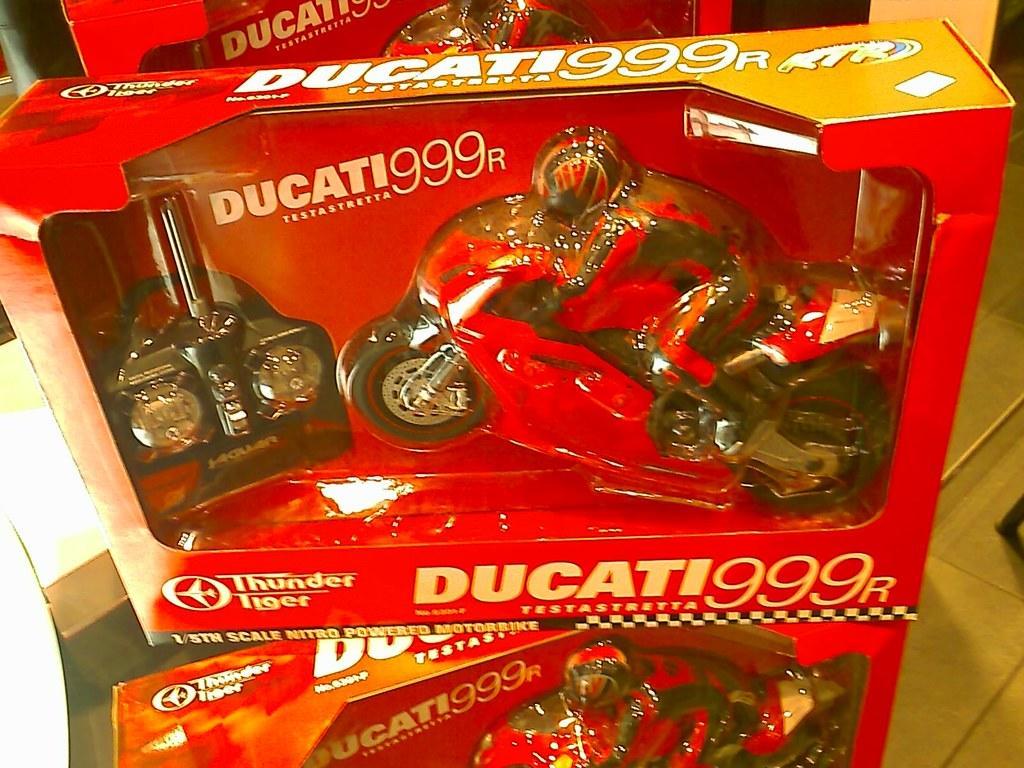Please provide a concise description of this image. In this picture we can see cotton boxes. In the cotton boxes we can see the toys and bikes which are kept on the table. On the right we can see the wooden floor. 